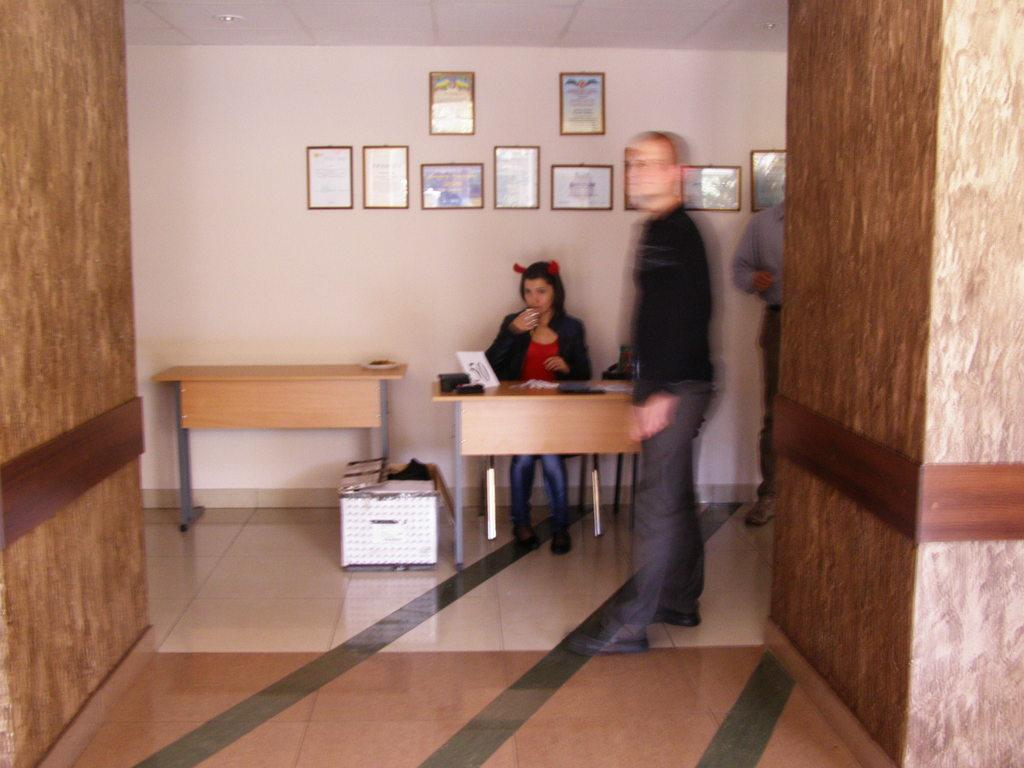How many people are in the image? There are two persons in the image. What are the positions of the two people in the image? One person is standing on the floor, and the other person is sitting on a bench. What can be seen on the wall in the image? There are paintings attached to the wall at the top of the image. What type of word is being spoken by the person sitting on the bench? There is no indication in the image that a word is being spoken, so it cannot be determined from the picture. 